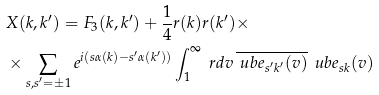<formula> <loc_0><loc_0><loc_500><loc_500>& X ( k , k ^ { \prime } ) = F _ { 3 } ( k , k ^ { \prime } ) + \frac { 1 } { 4 } r ( k ) r ( k ^ { \prime } ) \times \\ & \times \sum _ { s , s ^ { \prime } = \pm 1 } e ^ { i ( s \alpha ( k ) - s ^ { \prime } \alpha ( k ^ { \prime } ) ) } \int _ { 1 } ^ { \infty } \ r d v \, \overline { \ u b { e } _ { s ^ { \prime } k ^ { \prime } } ( v ) } \, \ u b { e } _ { s k } ( v )</formula> 